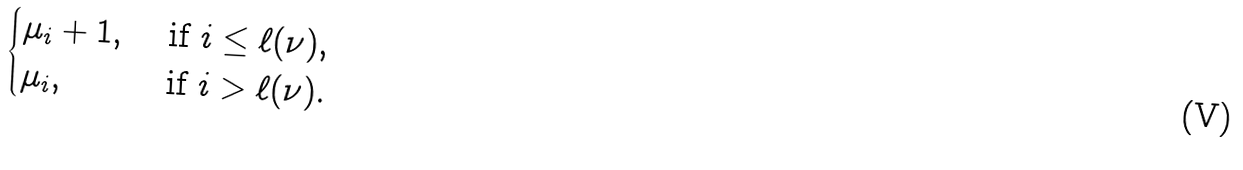<formula> <loc_0><loc_0><loc_500><loc_500>\begin{cases} \mu _ { i } + 1 , & \text { if $i\leq\ell(\nu)$,} \\ \mu _ { i } , & \text { if $i>\ell(\nu)$.} \end{cases}</formula> 